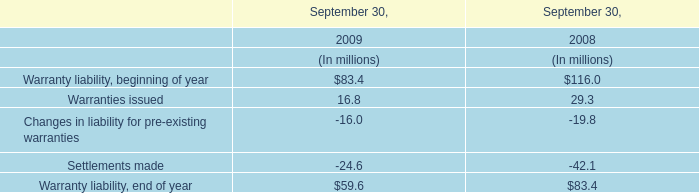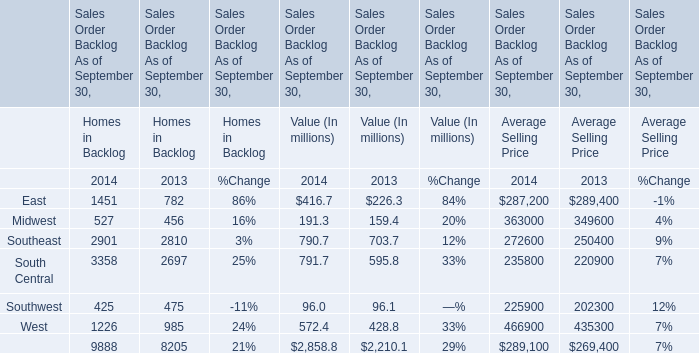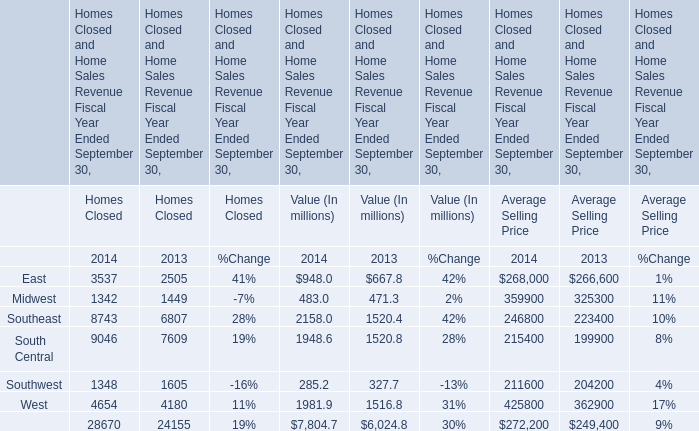In the year with largest amount of Southeast, what's the sum of Southeast? (in million) 
Computations: ((1342 + 483) + 359900)
Answer: 361725.0. 